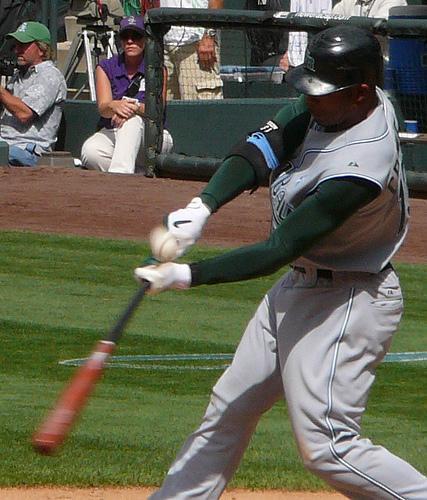How many people are up center?
Give a very brief answer. 1. How many people can be seen?
Give a very brief answer. 4. 